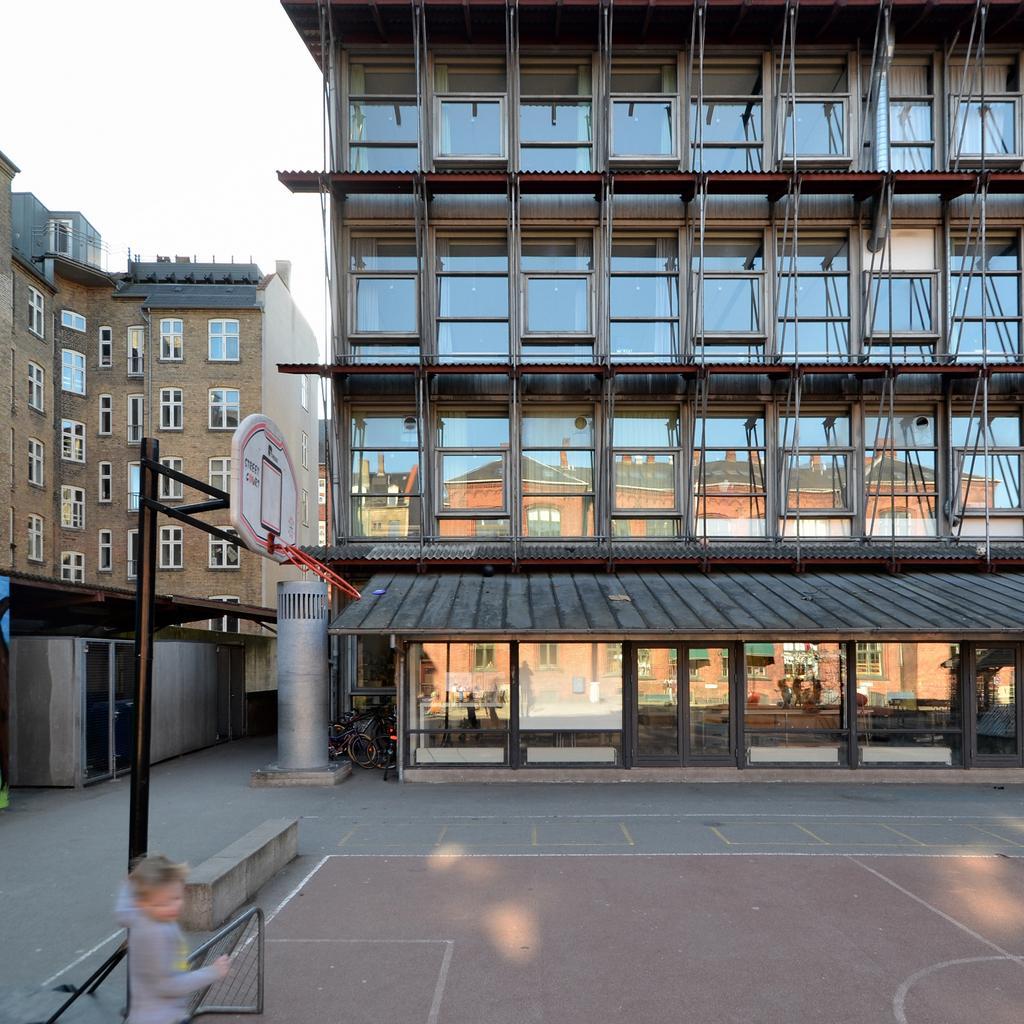Could you give a brief overview of what you see in this image? In this picture we can see buildings, we can see glass here, there is a person standing at the bottom, we can see the sky at the left top of the picture, there is a basketball post, we can see bicycle hire. 